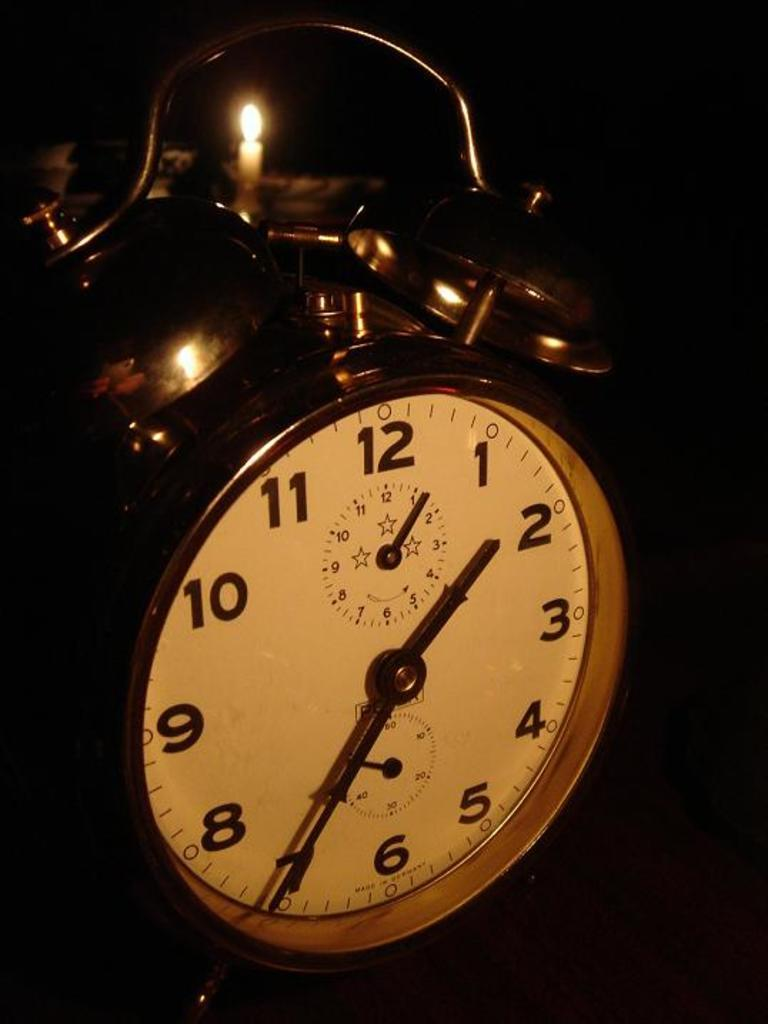<image>
Relay a brief, clear account of the picture shown. an old brass alarm clock by manufacturer beginning with letter P 